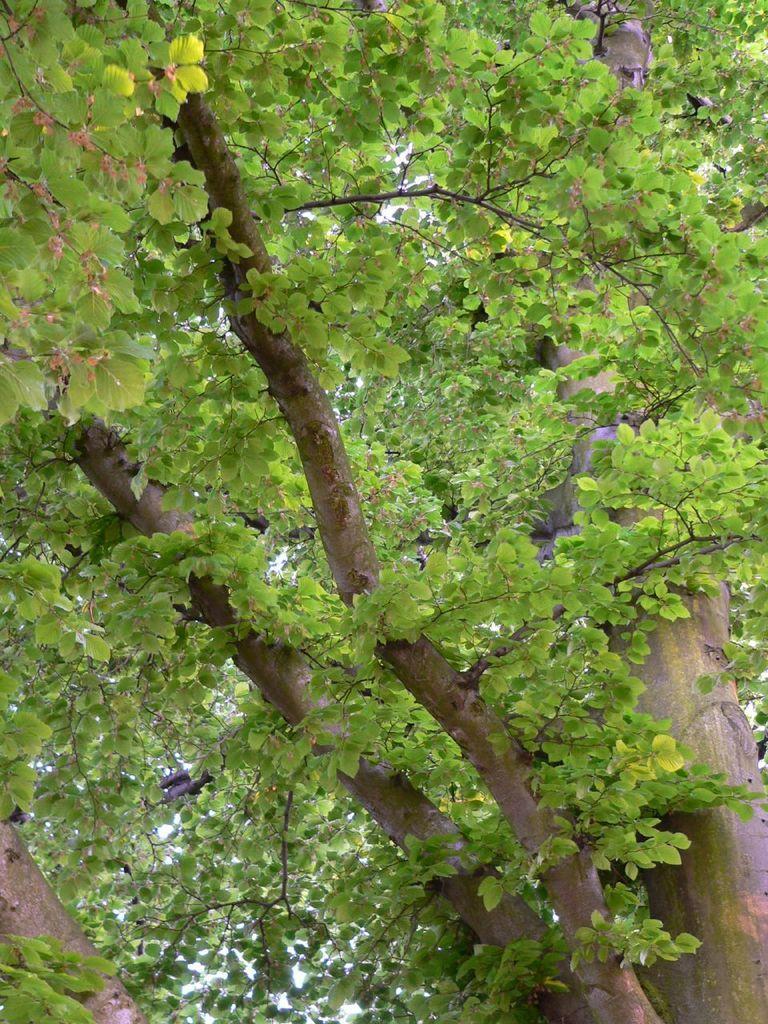How would you summarize this image in a sentence or two? In this image we can see a tree and sky. 